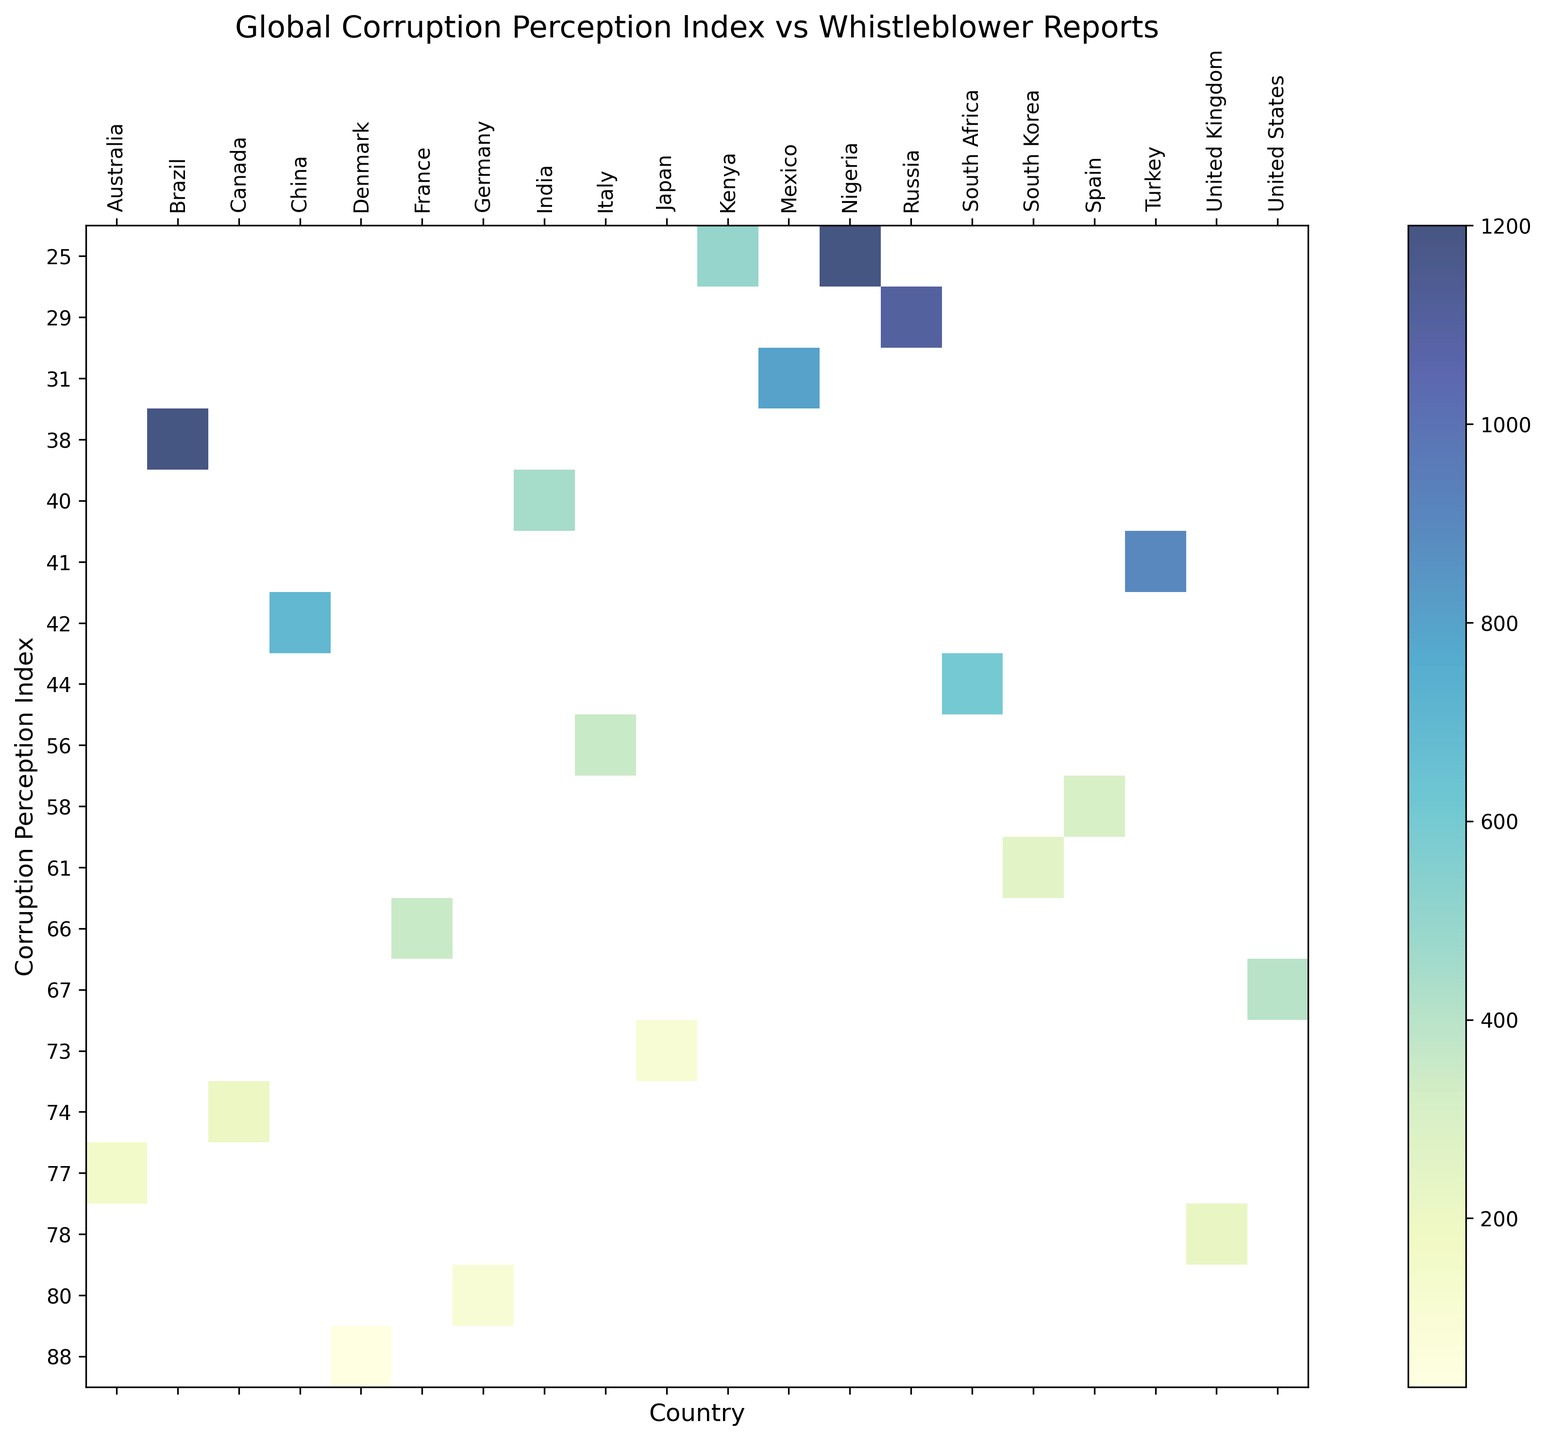Which country has the highest number of whistleblower reports? From the heatmap, observe the cell with the highest numerical value under the 'whistleblower_reports' category. Russia has the highest number of reports with 1100.
Answer: Russia Which country has the lowest Corruption Perception Index? Look at the vertical axis and identify the lowest value of the Corruption Perception Index. Nigeria and Kenya both have the lowest value of 25.
Answer: Nigeria and Kenya What's the average number of whistleblower reports for countries with a Corruption Perception Index above 70? List the countries with a CPI above 70: Australia, Canada, Denmark, Germany, Japan, United Kingdom. Sum their reports: (150 + 200 + 30 + 100 + 100 + 220) = 800. Divide by the number of countries: 800/6.
Answer: 133.3 Compare the whistleblower reports between countries with CPI below 50. Which country has the most significant difference in reports compared to Brazil? Identify countries with CPI below 50 (Brazil, India, Kenya, Mexico, Russia, South Africa, China, Turkey, Nigeria) and find reports. Brazil: 1200. Compare: India (450), Kenya (500), Mexico (800), Russia (1100), South Africa (600), China (700), Turkey (900), Nigeria (1200). Mexico has the most significant difference (800).
Answer: Mexico Which country has more whistleblower reports, France or Italy, and by how much? Compare the 'whistleblower_reports' values for France and Italy. France: 350, Italy: 350. Evaluate the difference: 350 - 350 = 0.
Answer: France; 0 What is the total number of whistleblower reports for countries with a CPI of exactly 44? Identify the countries with a CPI of 44: South Africa. Reference their reports: 600. Sum their reports: 600.
Answer: 600 How does the number of whistleblower reports for the United States compare to Turkey? Find the reports for the United States and Turkey: USA: 400, Turkey: 900. Compare the values: 900 - 400 = 500.
Answer: Turkey has 500 more reports What CPI corresponds to the highest number of whistleblower reports? Identify the cell with the maximum value under 'whistleblower_reports' and note its corresponding CPI. Russia with 1100 reports corresponds to a CPI of 29.
Answer: 29 Which country has a higher CPI, China or South Africa, and by how much? Compare the CPIs of China and South Africa. China: 42, South Africa: 44. Difference: 44 - 42 = 2.
Answer: South Africa; 2 How many countries have a CPI below 40? Count the number of countries with a CPI value less than 40 from the vertical axis. These countries are Brazil, Kenya, Mexico, Russia, Nigeria.
Answer: 5 